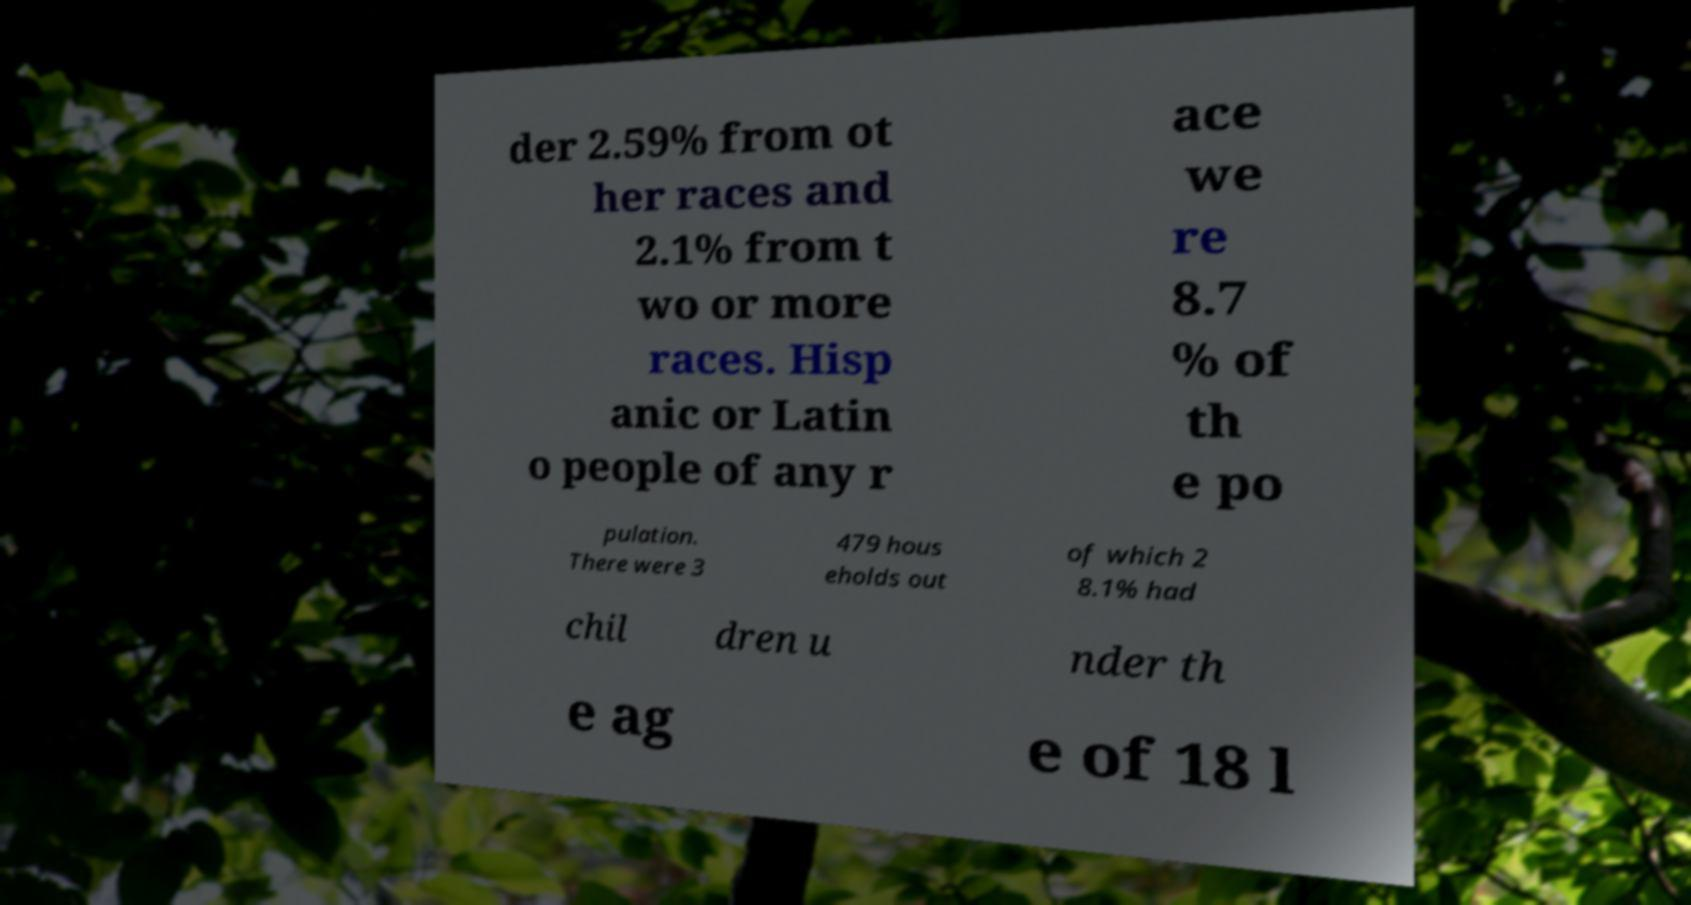For documentation purposes, I need the text within this image transcribed. Could you provide that? der 2.59% from ot her races and 2.1% from t wo or more races. Hisp anic or Latin o people of any r ace we re 8.7 % of th e po pulation. There were 3 479 hous eholds out of which 2 8.1% had chil dren u nder th e ag e of 18 l 